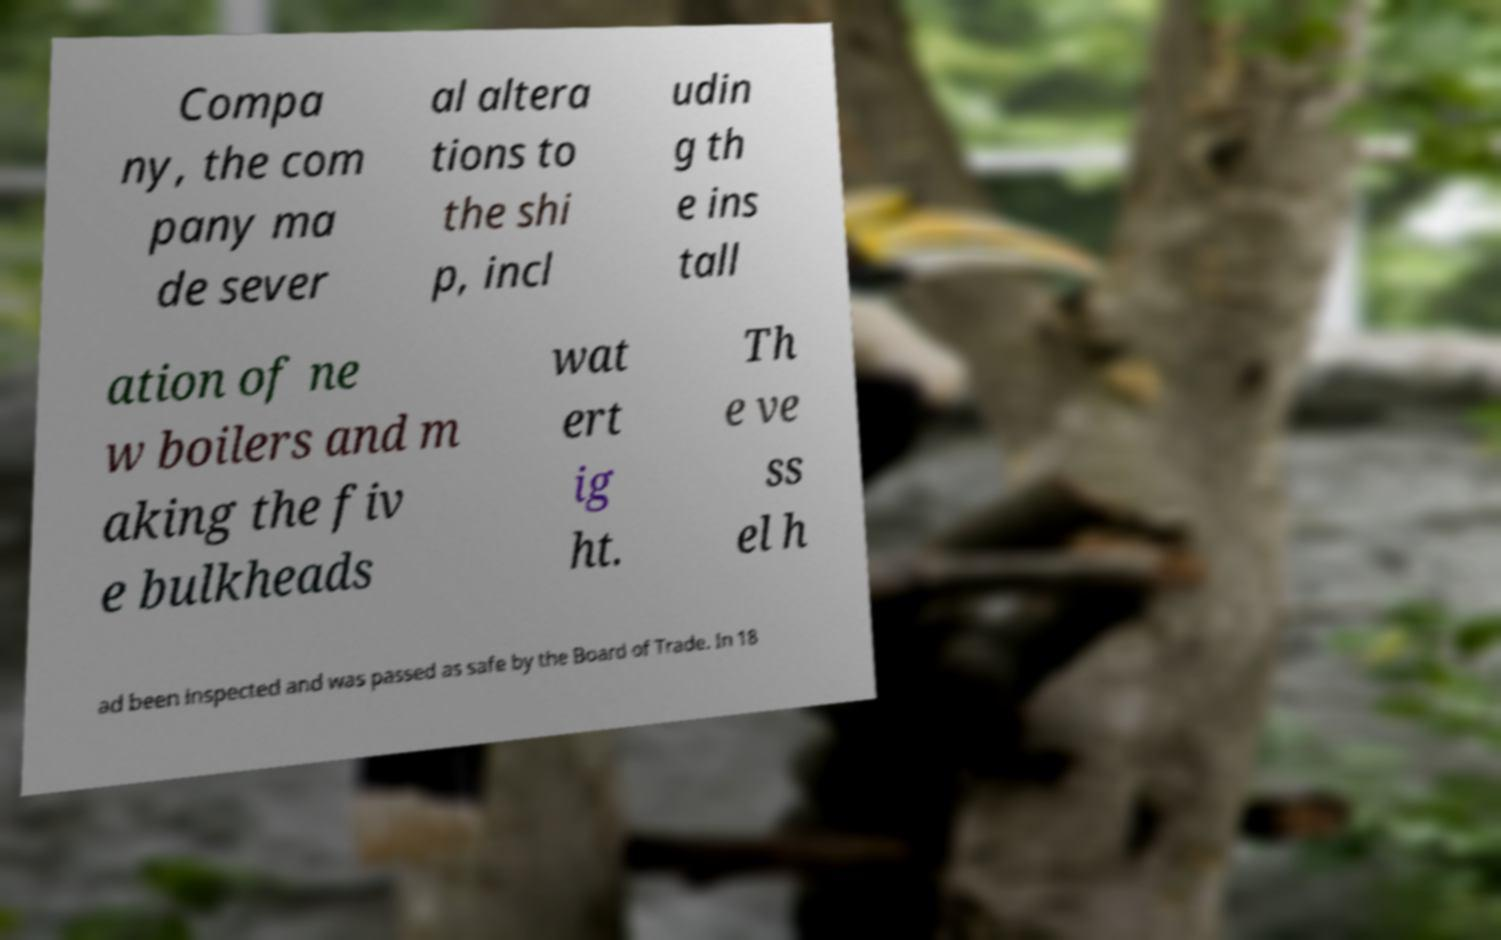Can you accurately transcribe the text from the provided image for me? Compa ny, the com pany ma de sever al altera tions to the shi p, incl udin g th e ins tall ation of ne w boilers and m aking the fiv e bulkheads wat ert ig ht. Th e ve ss el h ad been inspected and was passed as safe by the Board of Trade. In 18 